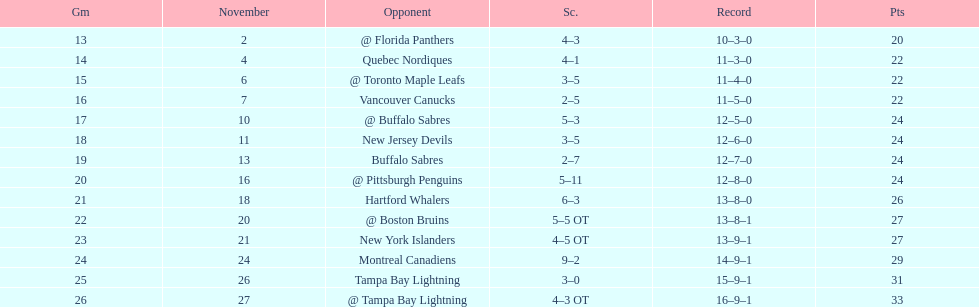Which was the only team in the atlantic division in the 1993-1994 season to acquire less points than the philadelphia flyers? Tampa Bay Lightning. 